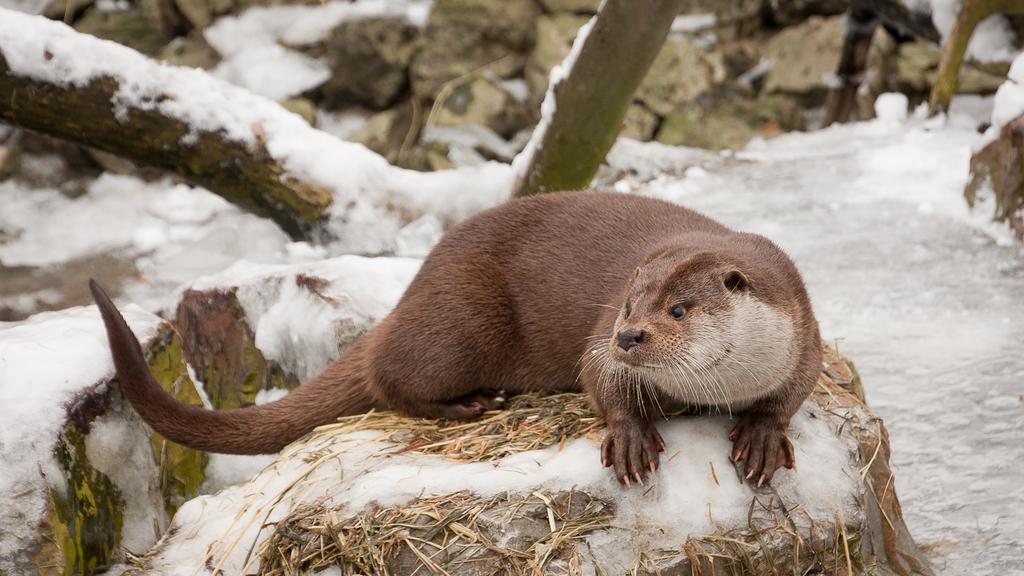Please provide a concise description of this image. In this picture, there is an animal on the stone. Behind it, there are stones and trees covered with the snow. 